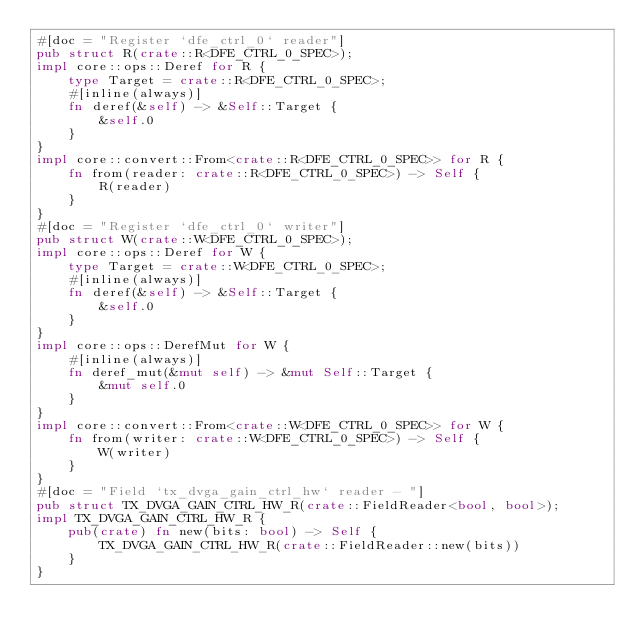Convert code to text. <code><loc_0><loc_0><loc_500><loc_500><_Rust_>#[doc = "Register `dfe_ctrl_0` reader"]
pub struct R(crate::R<DFE_CTRL_0_SPEC>);
impl core::ops::Deref for R {
    type Target = crate::R<DFE_CTRL_0_SPEC>;
    #[inline(always)]
    fn deref(&self) -> &Self::Target {
        &self.0
    }
}
impl core::convert::From<crate::R<DFE_CTRL_0_SPEC>> for R {
    fn from(reader: crate::R<DFE_CTRL_0_SPEC>) -> Self {
        R(reader)
    }
}
#[doc = "Register `dfe_ctrl_0` writer"]
pub struct W(crate::W<DFE_CTRL_0_SPEC>);
impl core::ops::Deref for W {
    type Target = crate::W<DFE_CTRL_0_SPEC>;
    #[inline(always)]
    fn deref(&self) -> &Self::Target {
        &self.0
    }
}
impl core::ops::DerefMut for W {
    #[inline(always)]
    fn deref_mut(&mut self) -> &mut Self::Target {
        &mut self.0
    }
}
impl core::convert::From<crate::W<DFE_CTRL_0_SPEC>> for W {
    fn from(writer: crate::W<DFE_CTRL_0_SPEC>) -> Self {
        W(writer)
    }
}
#[doc = "Field `tx_dvga_gain_ctrl_hw` reader - "]
pub struct TX_DVGA_GAIN_CTRL_HW_R(crate::FieldReader<bool, bool>);
impl TX_DVGA_GAIN_CTRL_HW_R {
    pub(crate) fn new(bits: bool) -> Self {
        TX_DVGA_GAIN_CTRL_HW_R(crate::FieldReader::new(bits))
    }
}</code> 